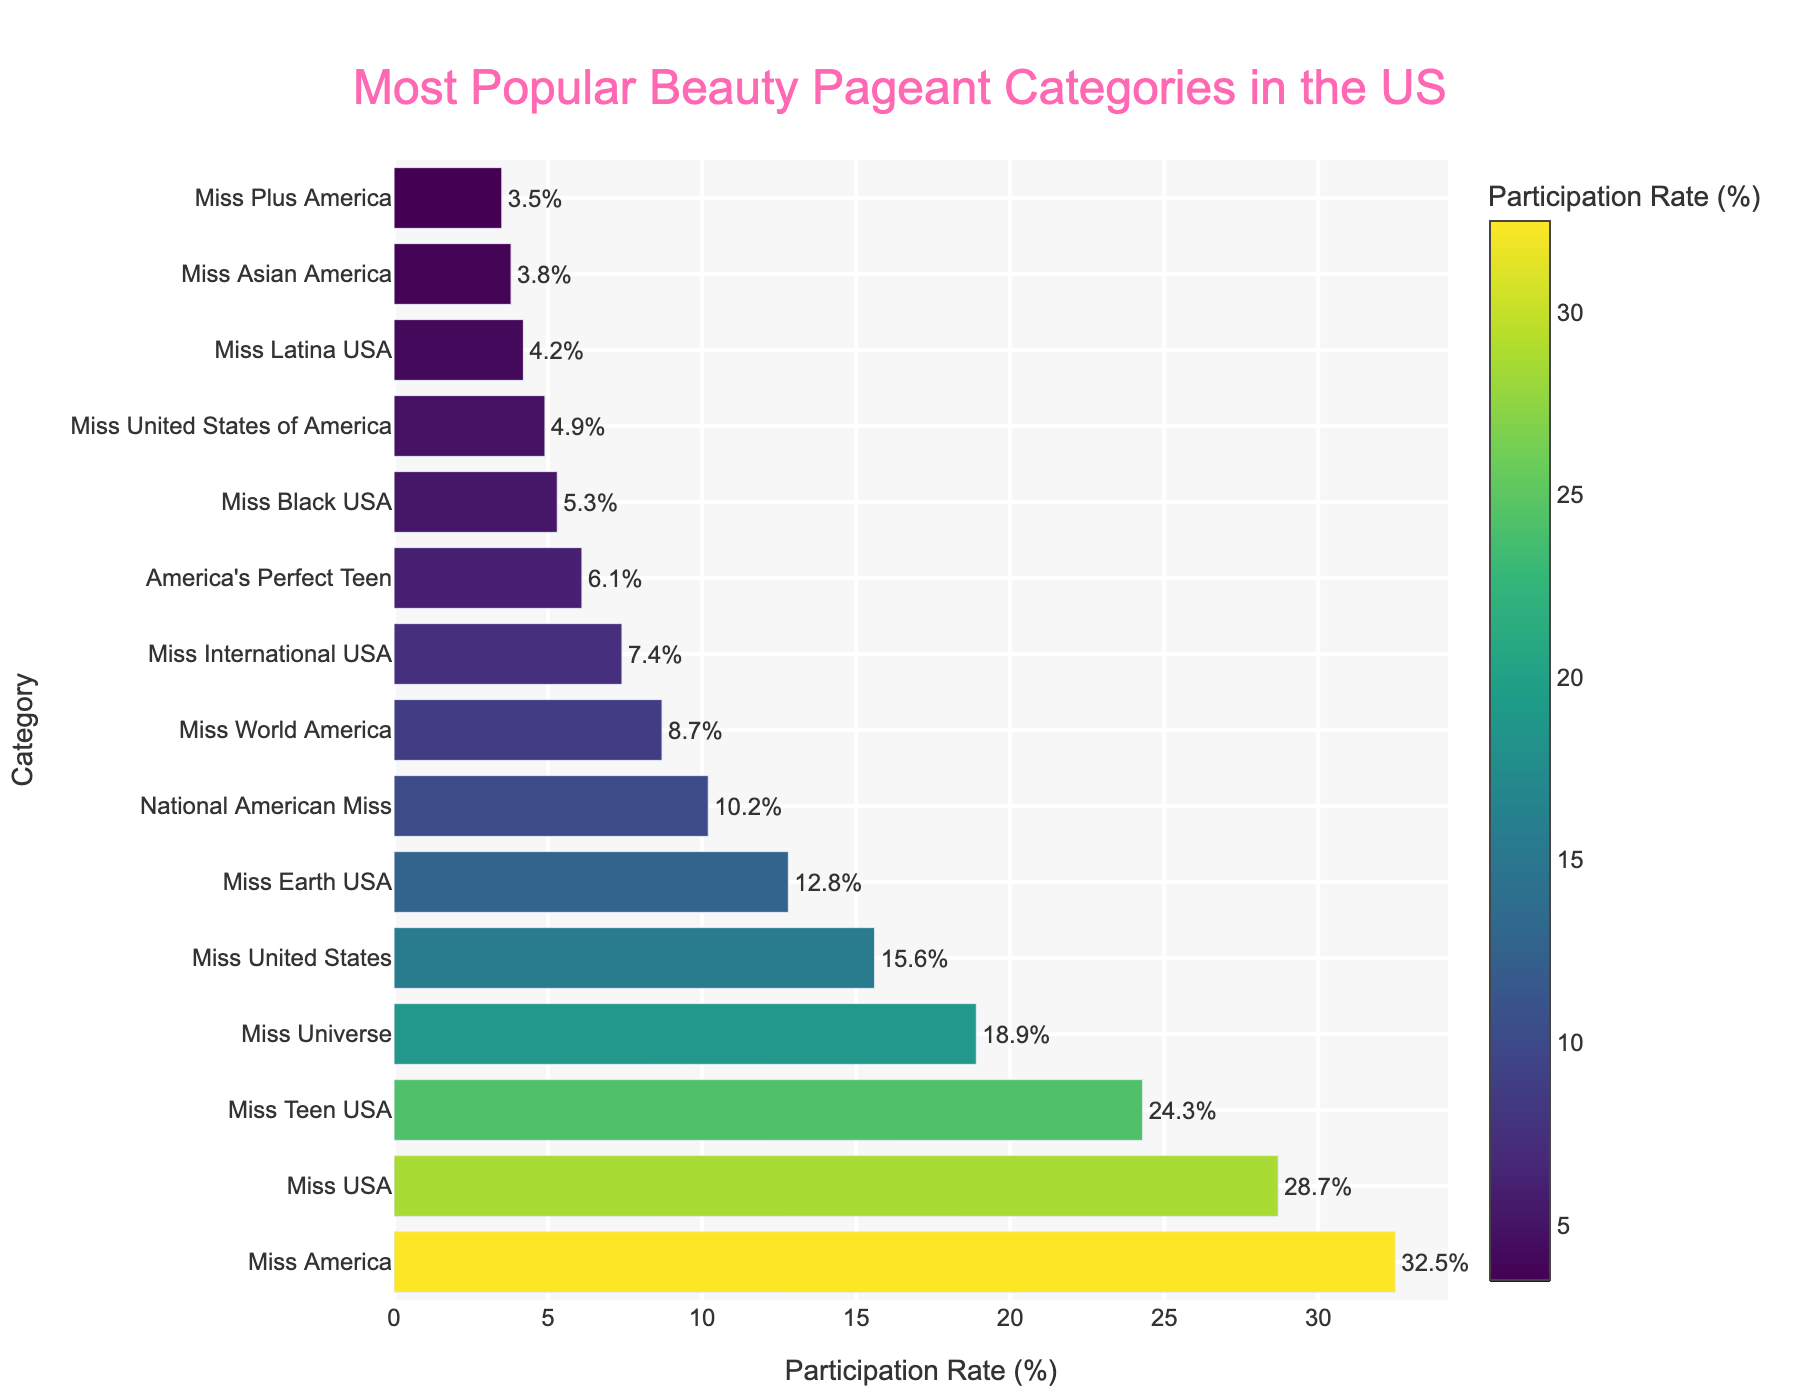Which beauty pageant category has the highest participation rate? The figure shows bar lengths based on participation rates. The longest bar represents the category with the highest participation rate, which is Miss America.
Answer: Miss America Which beauty pageant category has a participation rate of 18.9%? By reading the x-axis values corresponding to the bar lengths, you can find the bar that aligns with the 18.9% mark, which corresponds to Miss Universe.
Answer: Miss Universe What is the combined participation rate of Miss USA and Miss Teen USA categories? Miss USA has a participation rate of 28.7% and Miss Teen USA has a rate of 24.3%. Adding them together, 28.7% + 24.3% = 53.0%.
Answer: 53.0% How many more percentage points does Miss America have compared to Miss Earth USA? Miss America has a participation rate of 32.5% and Miss Earth USA has 12.8%. The difference is calculated as 32.5% - 12.8% = 19.7%.
Answer: 19.7% Which category is more popular, Miss Black USA or Miss United States of America? By comparing the bar lengths, Miss Black USA has a participation rate of 5.3% while Miss United States of America has 4.9%. Miss Black USA has a higher participation rate.
Answer: Miss Black USA What is the participation rate difference between the categories with the third and fourth highest rates? The third highest rate is Miss Teen USA at 24.3%, and the fourth highest is Miss Universe at 18.9%. The difference is 24.3% - 18.9% = 5.4%.
Answer: 5.4% Which category has the shortest bar and what is its participation rate? The shortest bar, at the bottom of the y-axis, represents Miss Plus America. By reading the x-axis value, its participation rate is 3.5%.
Answer: Miss Plus America, 3.5% Is National American Miss more or less popular than Miss Earth USA? By comparing the bar lengths, National American Miss has a participation rate of 10.2% while Miss Earth USA has 12.8%. National American Miss is less popular.
Answer: Less What is the average participation rate of the top three categories? The top three categories are Miss America (32.5%), Miss USA (28.7%), and Miss Teen USA (24.3%). Adding them: 32.5% + 28.7% + 24.3% = 85.5%. Dividing by 3, the average is 85.5% / 3 = 28.5%.
Answer: 28.5% How many categories have a participation rate less than 10%? By inspecting the chart, the categories with participation rates less than 10% are Miss World America, Miss International USA, America's Perfect Teen, Miss Black USA, Miss United States of America, Miss Latina USA, Miss Asian America, and Miss Plus America. Counting them, there are 8 categories.
Answer: 8 